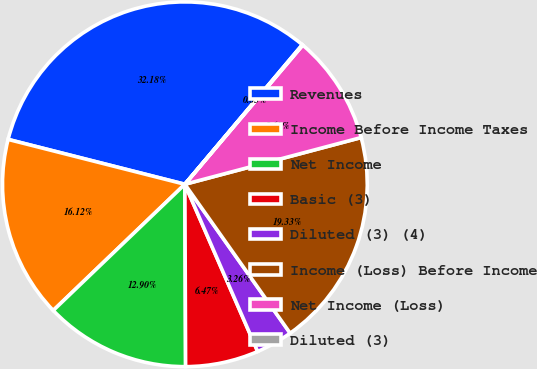<chart> <loc_0><loc_0><loc_500><loc_500><pie_chart><fcel>Revenues<fcel>Income Before Income Taxes<fcel>Net Income<fcel>Basic (3)<fcel>Diluted (3) (4)<fcel>Income (Loss) Before Income<fcel>Net Income (Loss)<fcel>Diluted (3)<nl><fcel>32.18%<fcel>16.12%<fcel>12.9%<fcel>6.47%<fcel>3.26%<fcel>19.33%<fcel>9.69%<fcel>0.05%<nl></chart> 